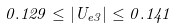<formula> <loc_0><loc_0><loc_500><loc_500>0 . 1 2 9 \leq | U _ { e 3 } | \leq 0 . 1 4 1</formula> 